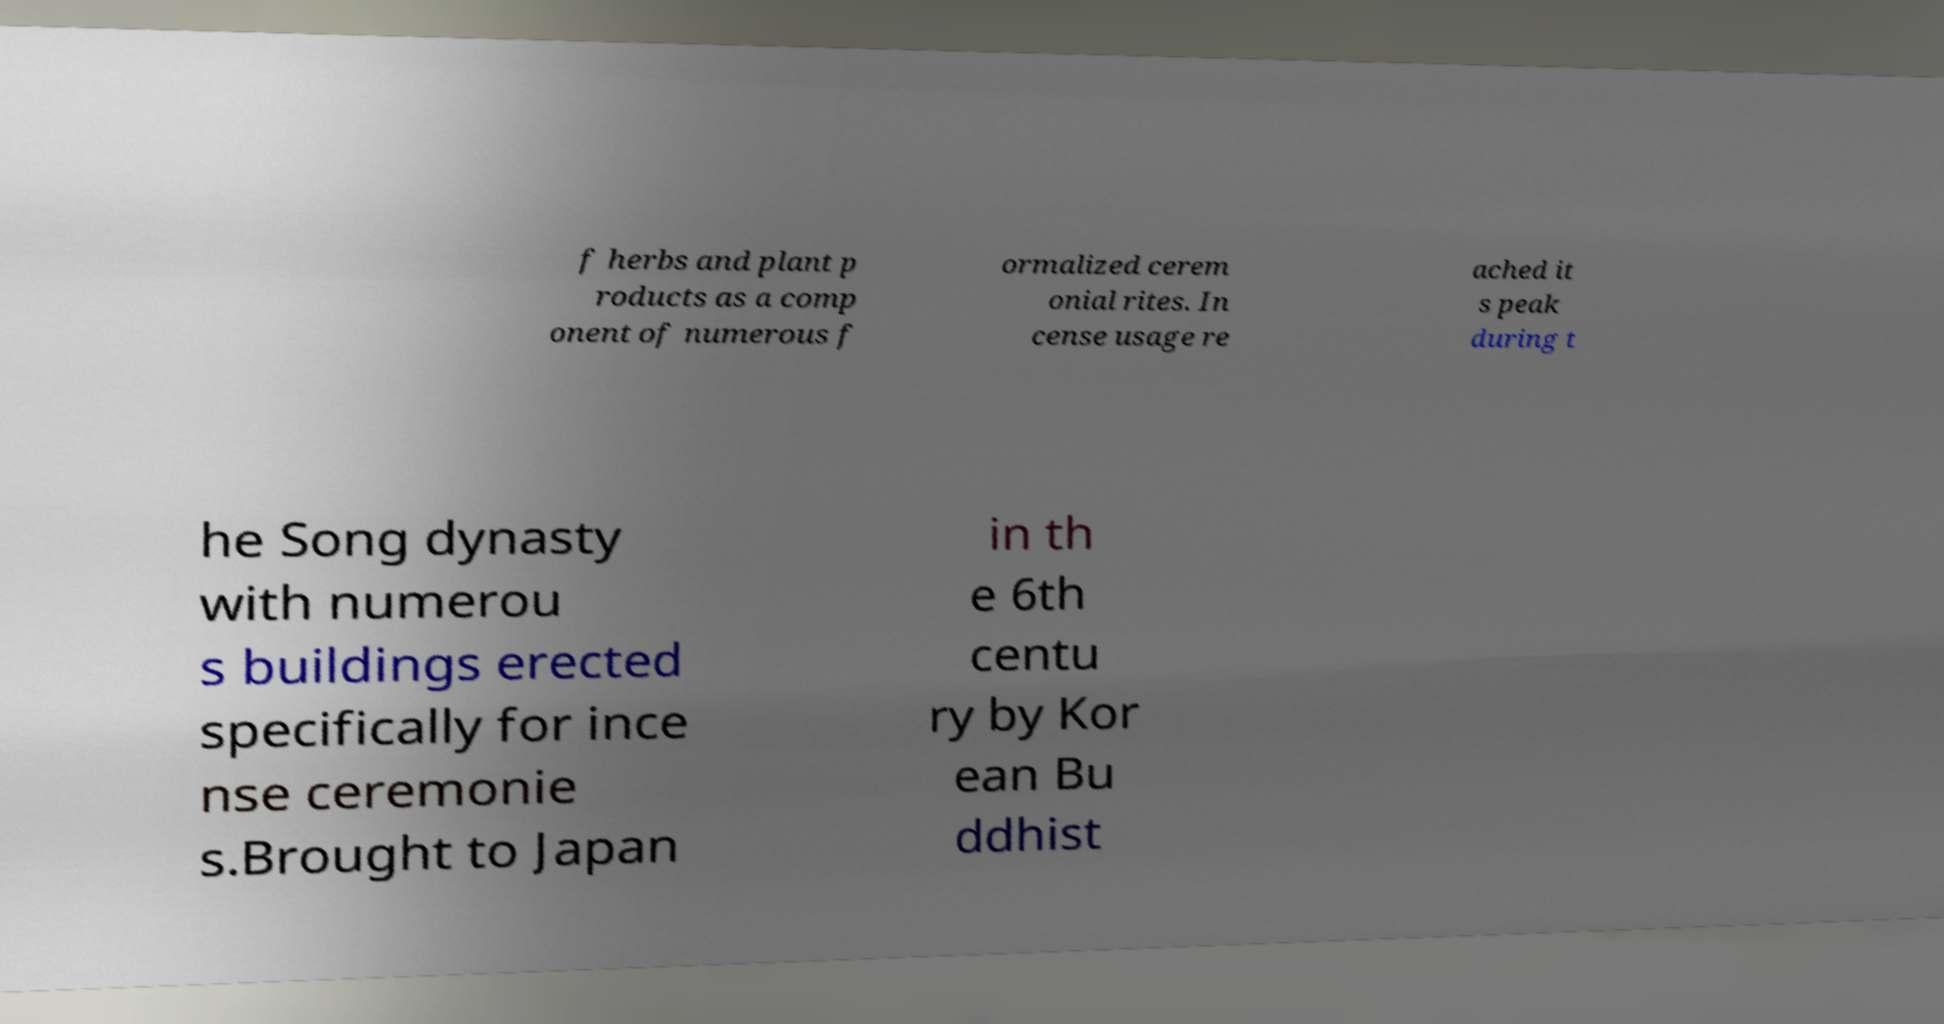Please identify and transcribe the text found in this image. f herbs and plant p roducts as a comp onent of numerous f ormalized cerem onial rites. In cense usage re ached it s peak during t he Song dynasty with numerou s buildings erected specifically for ince nse ceremonie s.Brought to Japan in th e 6th centu ry by Kor ean Bu ddhist 